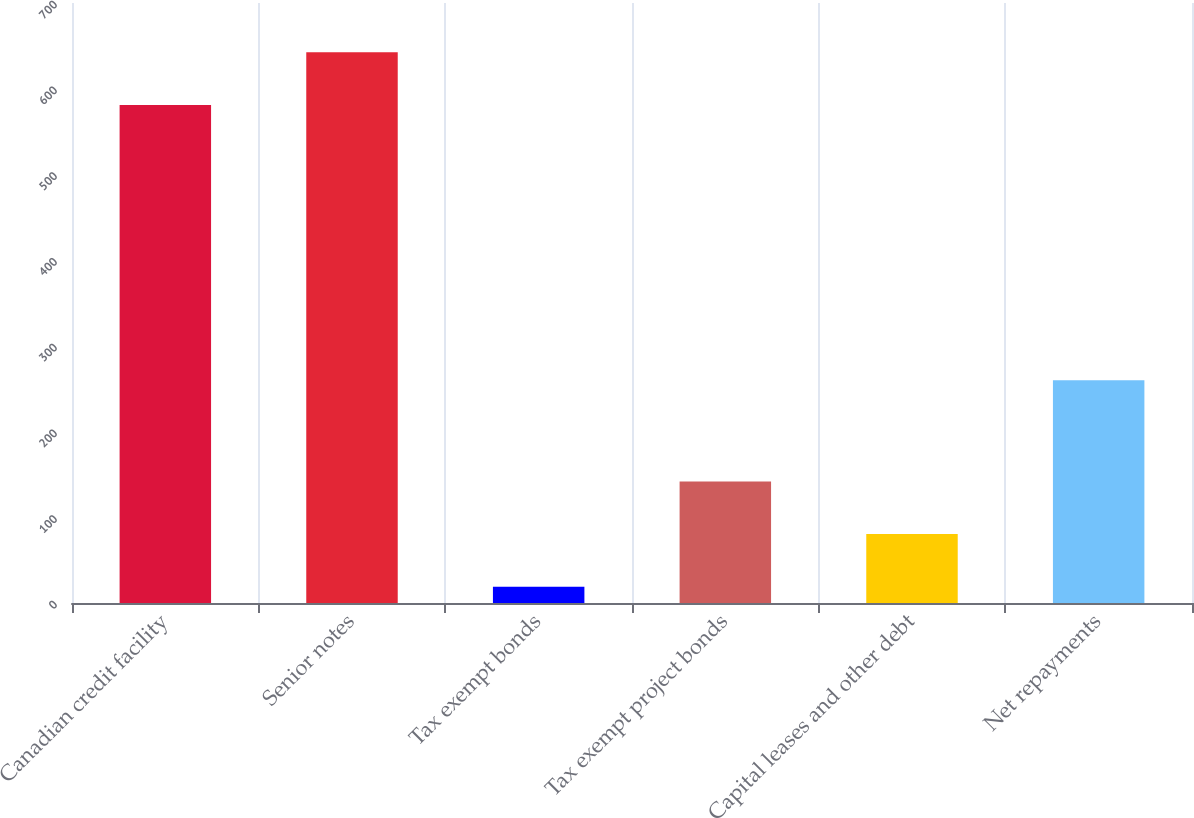<chart> <loc_0><loc_0><loc_500><loc_500><bar_chart><fcel>Canadian credit facility<fcel>Senior notes<fcel>Tax exempt bonds<fcel>Tax exempt project bonds<fcel>Capital leases and other debt<fcel>Net repayments<nl><fcel>581<fcel>642.4<fcel>19<fcel>141.8<fcel>80.4<fcel>260<nl></chart> 